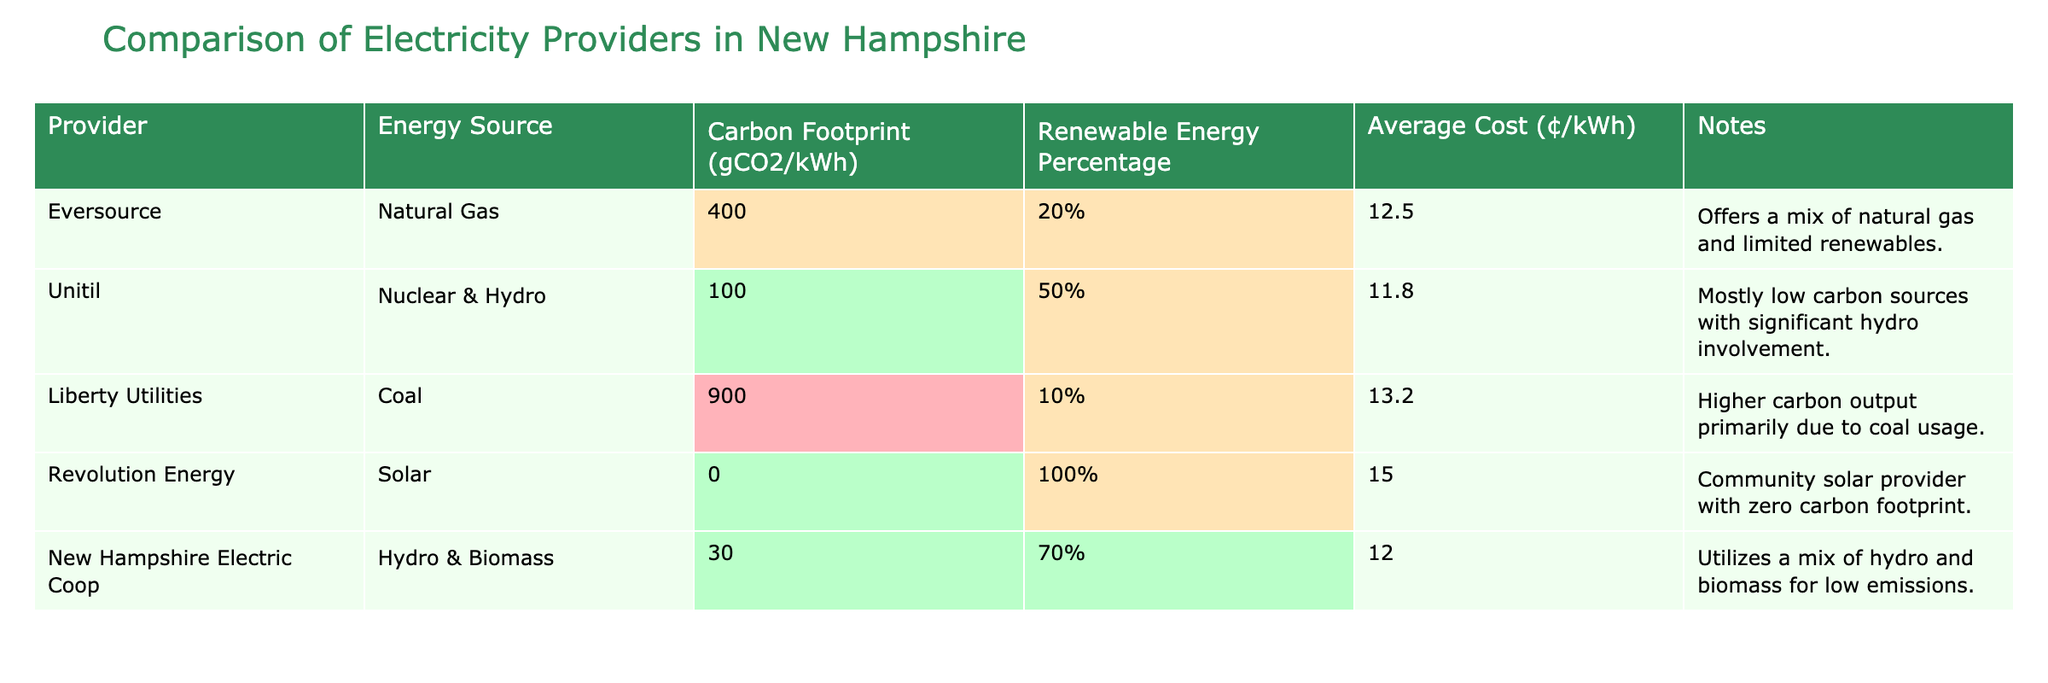What is the carbon footprint of Eversource? The table lists Eversource with a carbon footprint of 400 gCO2/kWh.
Answer: 400 gCO2/kWh Which provider has the lowest carbon footprint? Revolution Energy has a carbon footprint of 0 gCO2/kWh, which is the lowest among all providers listed.
Answer: Revolution Energy What percentage of renewable energy does Liberty Utilities offer? Liberty Utilities has a renewable energy percentage of 10%, as stated in the table.
Answer: 10% Calculate the average carbon footprint of the providers listed. The carbon footprints are 400, 100, 900, 0, and 30 gCO2/kWh. Summing them gives 1430. There are 5 providers, so the average is 1430/5 = 286 gCO2/kWh.
Answer: 286 gCO2/kWh Is Unitil considered a low carbon provider? Unitil has a carbon footprint of 100 gCO2/kWh and a renewable energy percentage of 50%, indicating it's mostly low carbon. Thus, it can be considered a low carbon provider.
Answer: Yes How much more does Liberty Utilities charge compared to Revolution Energy? Liberty Utilities charges 13.2¢/kWh and Revolution Energy charges 15.0¢/kWh. The difference is 15.0 - 13.2 = 1.8¢/kWh.
Answer: 1.8¢/kWh Which provider has the highest renewable energy percentage and what is it? Revolution Energy has a 100% renewable energy percentage, which is the highest among the providers listed.
Answer: 100% Does New Hampshire Electric Coop utilize any fossil fuels? The table indicates that New Hampshire Electric Coop uses hydro and biomass, which are not fossil fuels, so they do not utilize fossil fuels.
Answer: No What is the average cost of electricity among all providers? The average cost is calculated as (12.5 + 11.8 + 13.2 + 15.0 + 12.0)/5, which equals 12.5¢/kWh.
Answer: 12.5¢/kWh How many providers have a carbon footprint under 200 gCO2/kWh? The providers with carbon footprints under 200 gCO2/kWh are Unitil (100), Revolution Energy (0), and New Hampshire Electric Coop (30), totaling three providers.
Answer: 3 